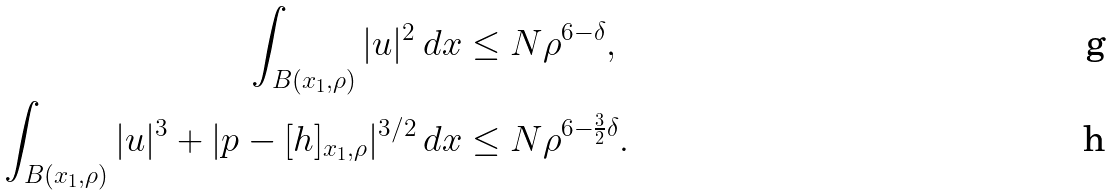<formula> <loc_0><loc_0><loc_500><loc_500>\int _ { B ( x _ { 1 } , \rho ) } | u | ^ { 2 } \, d x & \leq N \rho ^ { 6 - \delta } , \\ \int _ { B ( x _ { 1 } , \rho ) } | u | ^ { 3 } + | p - [ h ] _ { x _ { 1 } , \rho } | ^ { 3 / 2 } \, d x & \leq N \rho ^ { 6 - \frac { 3 } { 2 } \delta } .</formula> 